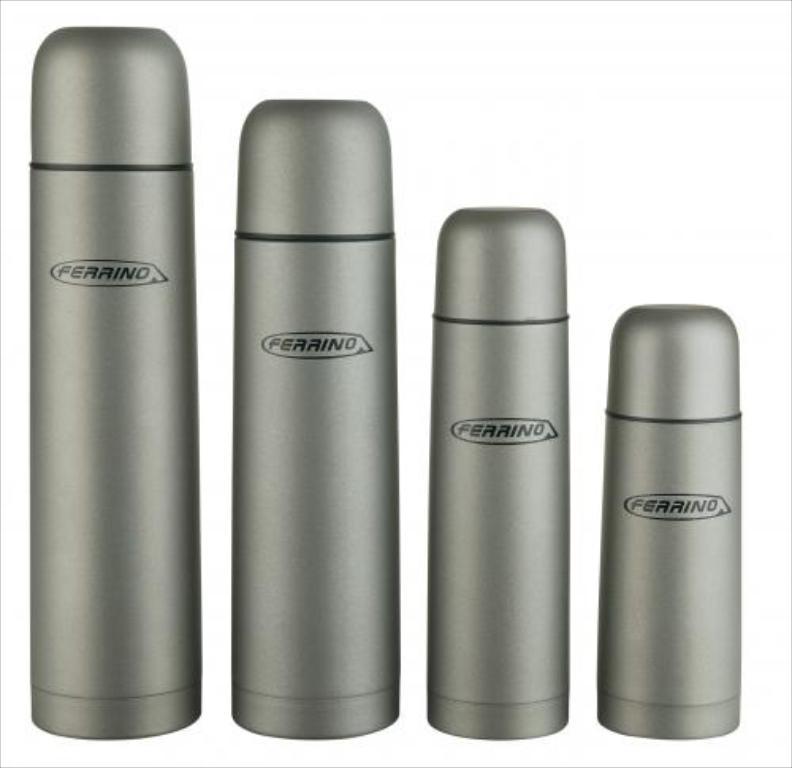What is the brand of thermos?
Give a very brief answer. Ferrino. 